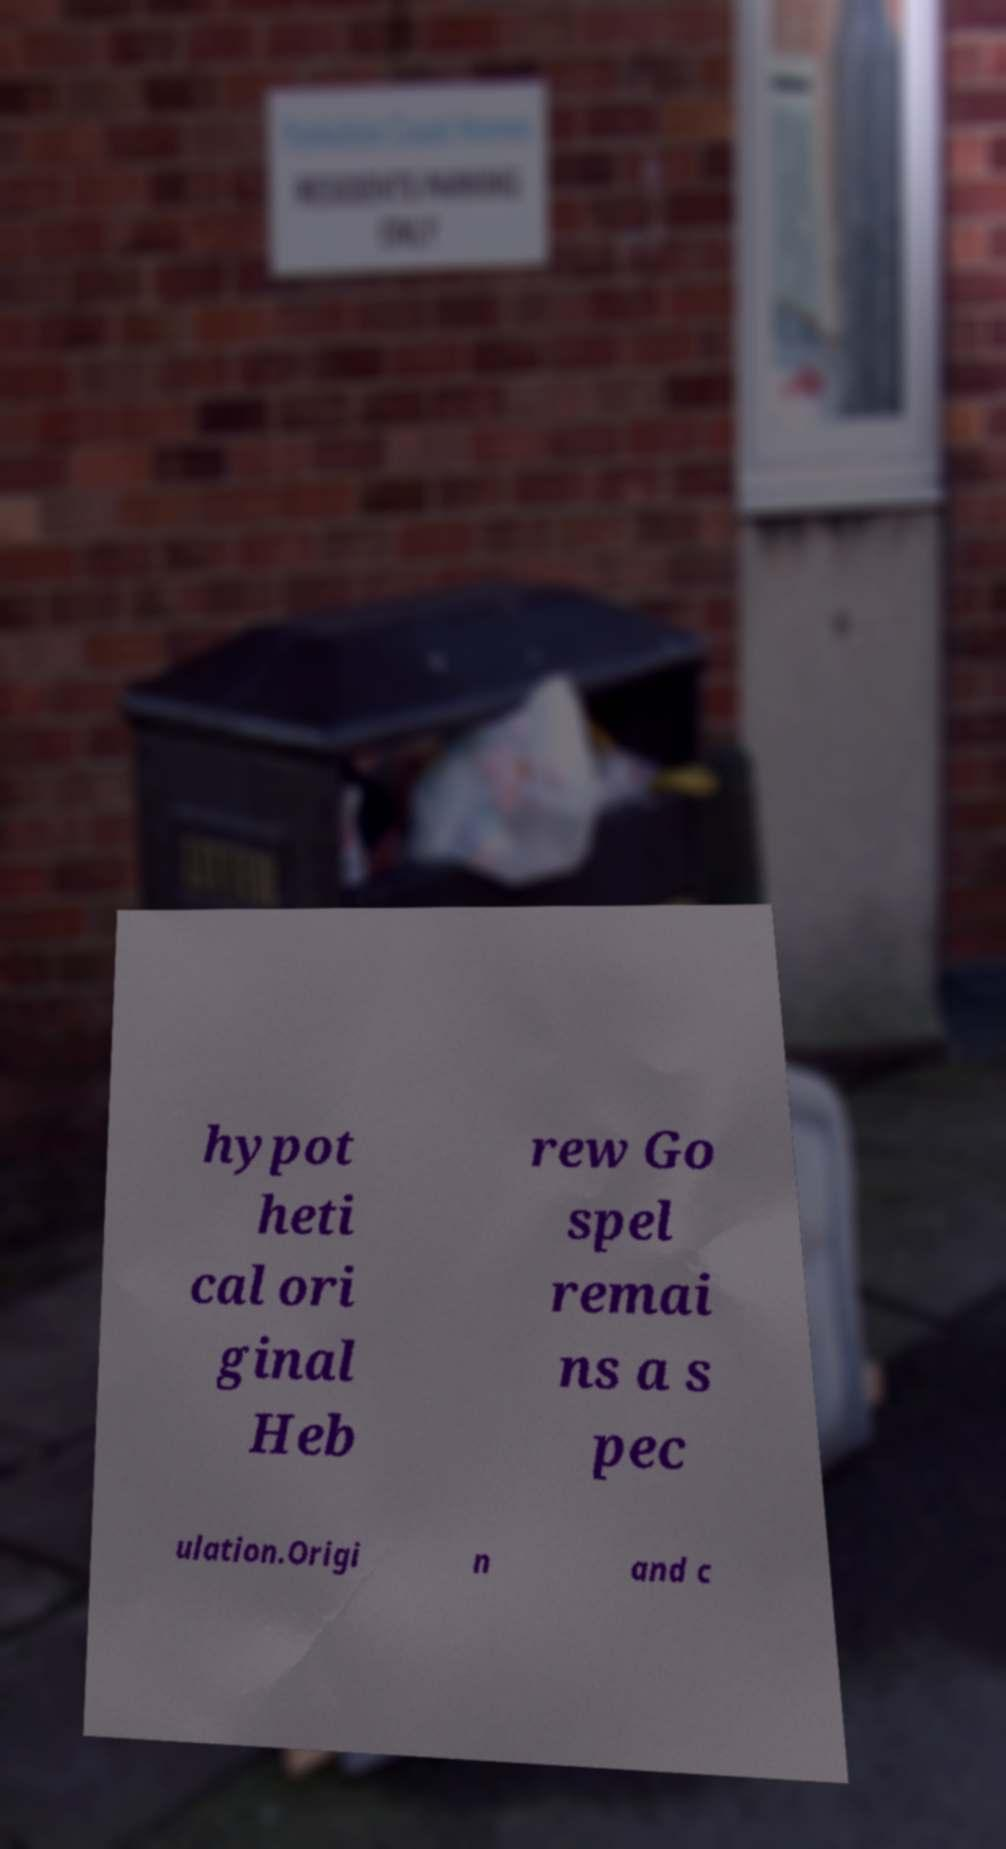Can you read and provide the text displayed in the image?This photo seems to have some interesting text. Can you extract and type it out for me? hypot heti cal ori ginal Heb rew Go spel remai ns a s pec ulation.Origi n and c 